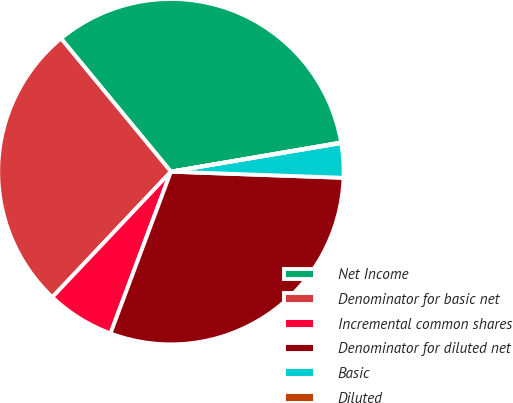Convert chart. <chart><loc_0><loc_0><loc_500><loc_500><pie_chart><fcel>Net Income<fcel>Denominator for basic net<fcel>Incremental common shares<fcel>Denominator for diluted net<fcel>Basic<fcel>Diluted<nl><fcel>33.27%<fcel>26.97%<fcel>6.36%<fcel>30.12%<fcel>3.21%<fcel>0.06%<nl></chart> 